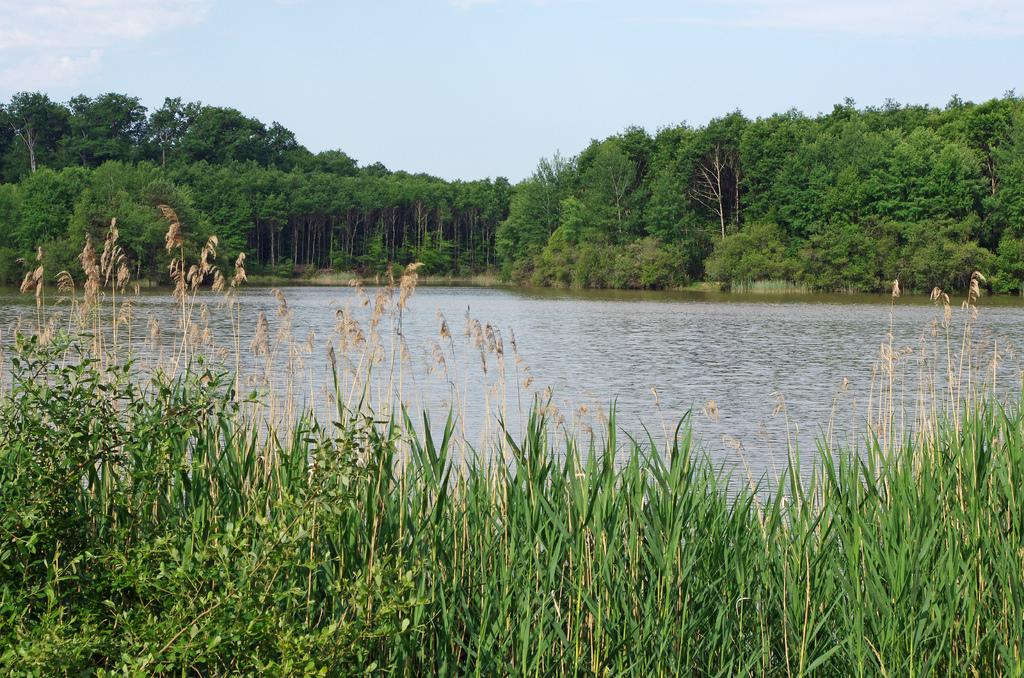What type of vegetation can be seen in the image? There is grass in the image. What else is visible besides the grass? There is water visible in the image. What can be seen in the background of the image? There are trees and clouds in the sky. What type of brush can be seen in the image? There is no brush present in the image. What does the voice of the visitor sound like in the image? There is no visitor or voice present in the image. 